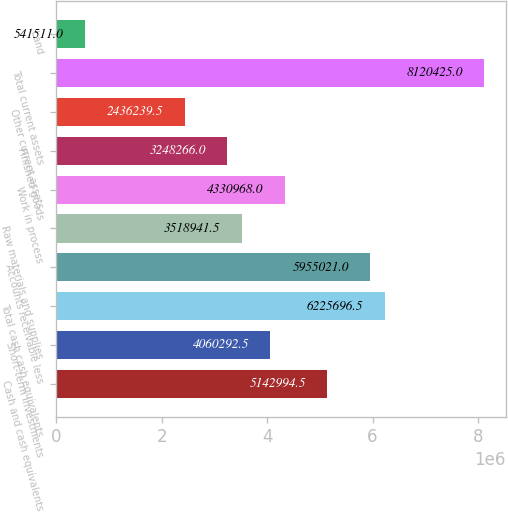<chart> <loc_0><loc_0><loc_500><loc_500><bar_chart><fcel>Cash and cash equivalents<fcel>Short-term investments<fcel>Total cash cash equivalents<fcel>Accounts receivable less<fcel>Raw materials and supplies<fcel>Work in process<fcel>Finished goods<fcel>Other current assets<fcel>Total current assets<fcel>Land<nl><fcel>5.14299e+06<fcel>4.06029e+06<fcel>6.2257e+06<fcel>5.95502e+06<fcel>3.51894e+06<fcel>4.33097e+06<fcel>3.24827e+06<fcel>2.43624e+06<fcel>8.12042e+06<fcel>541511<nl></chart> 